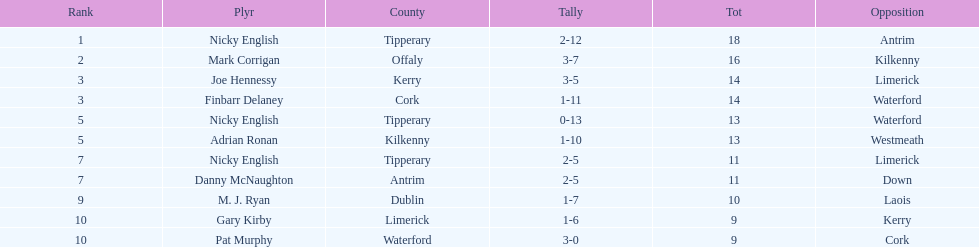What is the least total on the list? 9. 